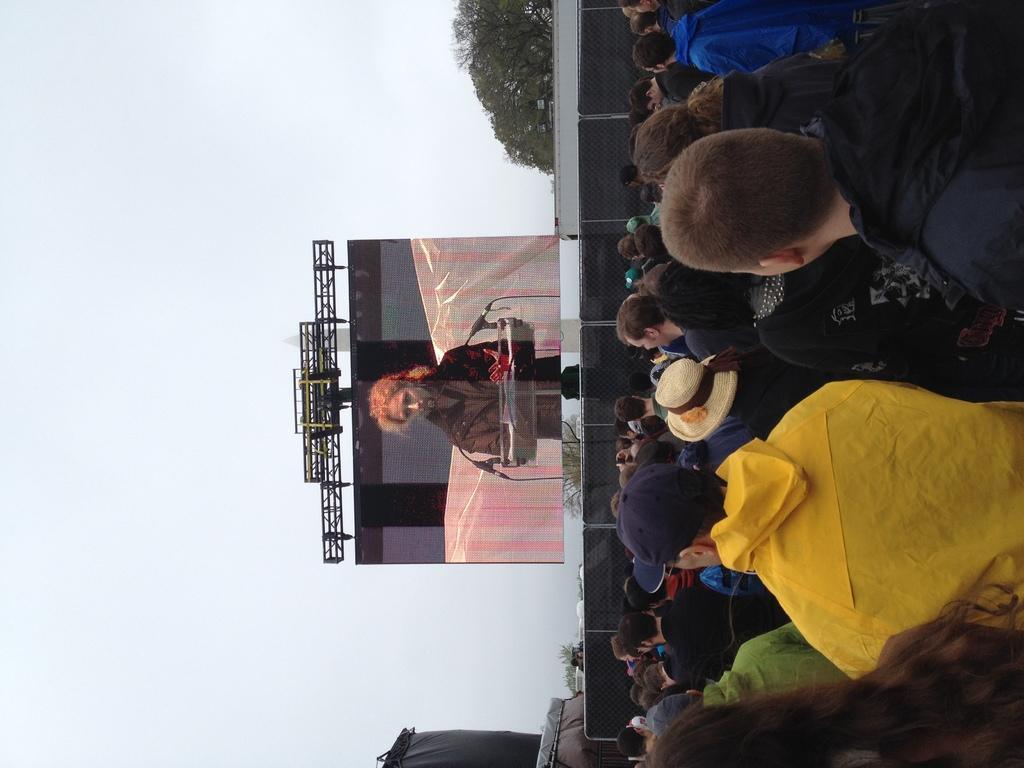In one or two sentences, can you explain what this image depicts? This image is taken outdoors. On the left side of the image there is the sky. On the right side of the image there are many people. In the middle of the image there are two trees. There is a dais. There is a screen and there are many iron bars. 